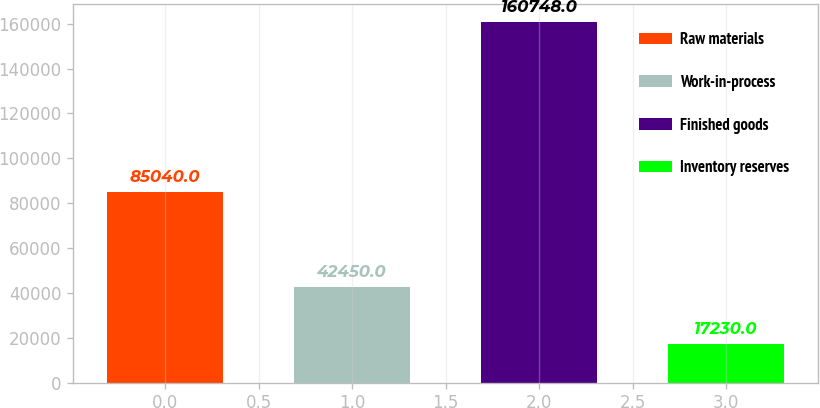<chart> <loc_0><loc_0><loc_500><loc_500><bar_chart><fcel>Raw materials<fcel>Work-in-process<fcel>Finished goods<fcel>Inventory reserves<nl><fcel>85040<fcel>42450<fcel>160748<fcel>17230<nl></chart> 